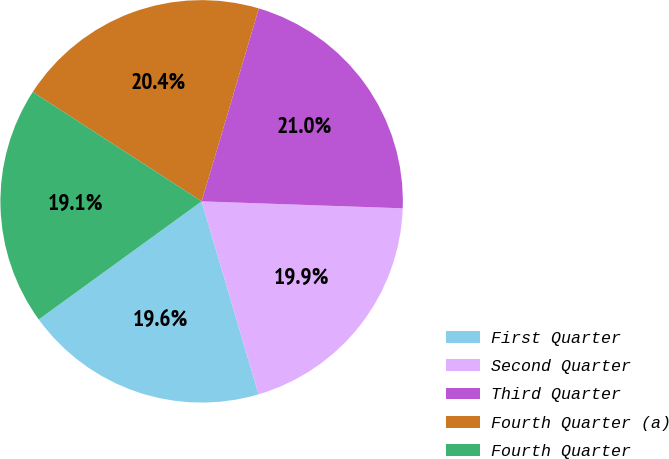Convert chart. <chart><loc_0><loc_0><loc_500><loc_500><pie_chart><fcel>First Quarter<fcel>Second Quarter<fcel>Third Quarter<fcel>Fourth Quarter (a)<fcel>Fourth Quarter<nl><fcel>19.58%<fcel>19.88%<fcel>20.96%<fcel>20.44%<fcel>19.13%<nl></chart> 